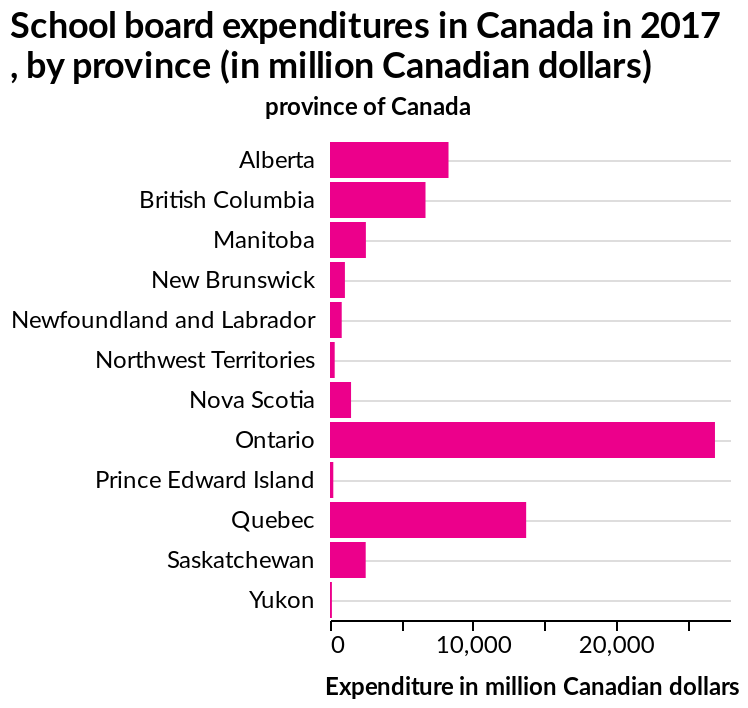<image>
What does the x-axis measure on the bar plot?  The x-axis measures the expenditure in million Canadian dollars. Which region is highlighted as having the highest expenditure? Ontario is highlighted as the region with the highest expenditure. What does the figure say about Ontario's expenditure compared to others? The figure states that Ontario has the highest expenditure compared to the others. Does the figure falsely claim that Ontario has the highest expenditure compared to the others? No.The figure states that Ontario has the highest expenditure compared to the others. 